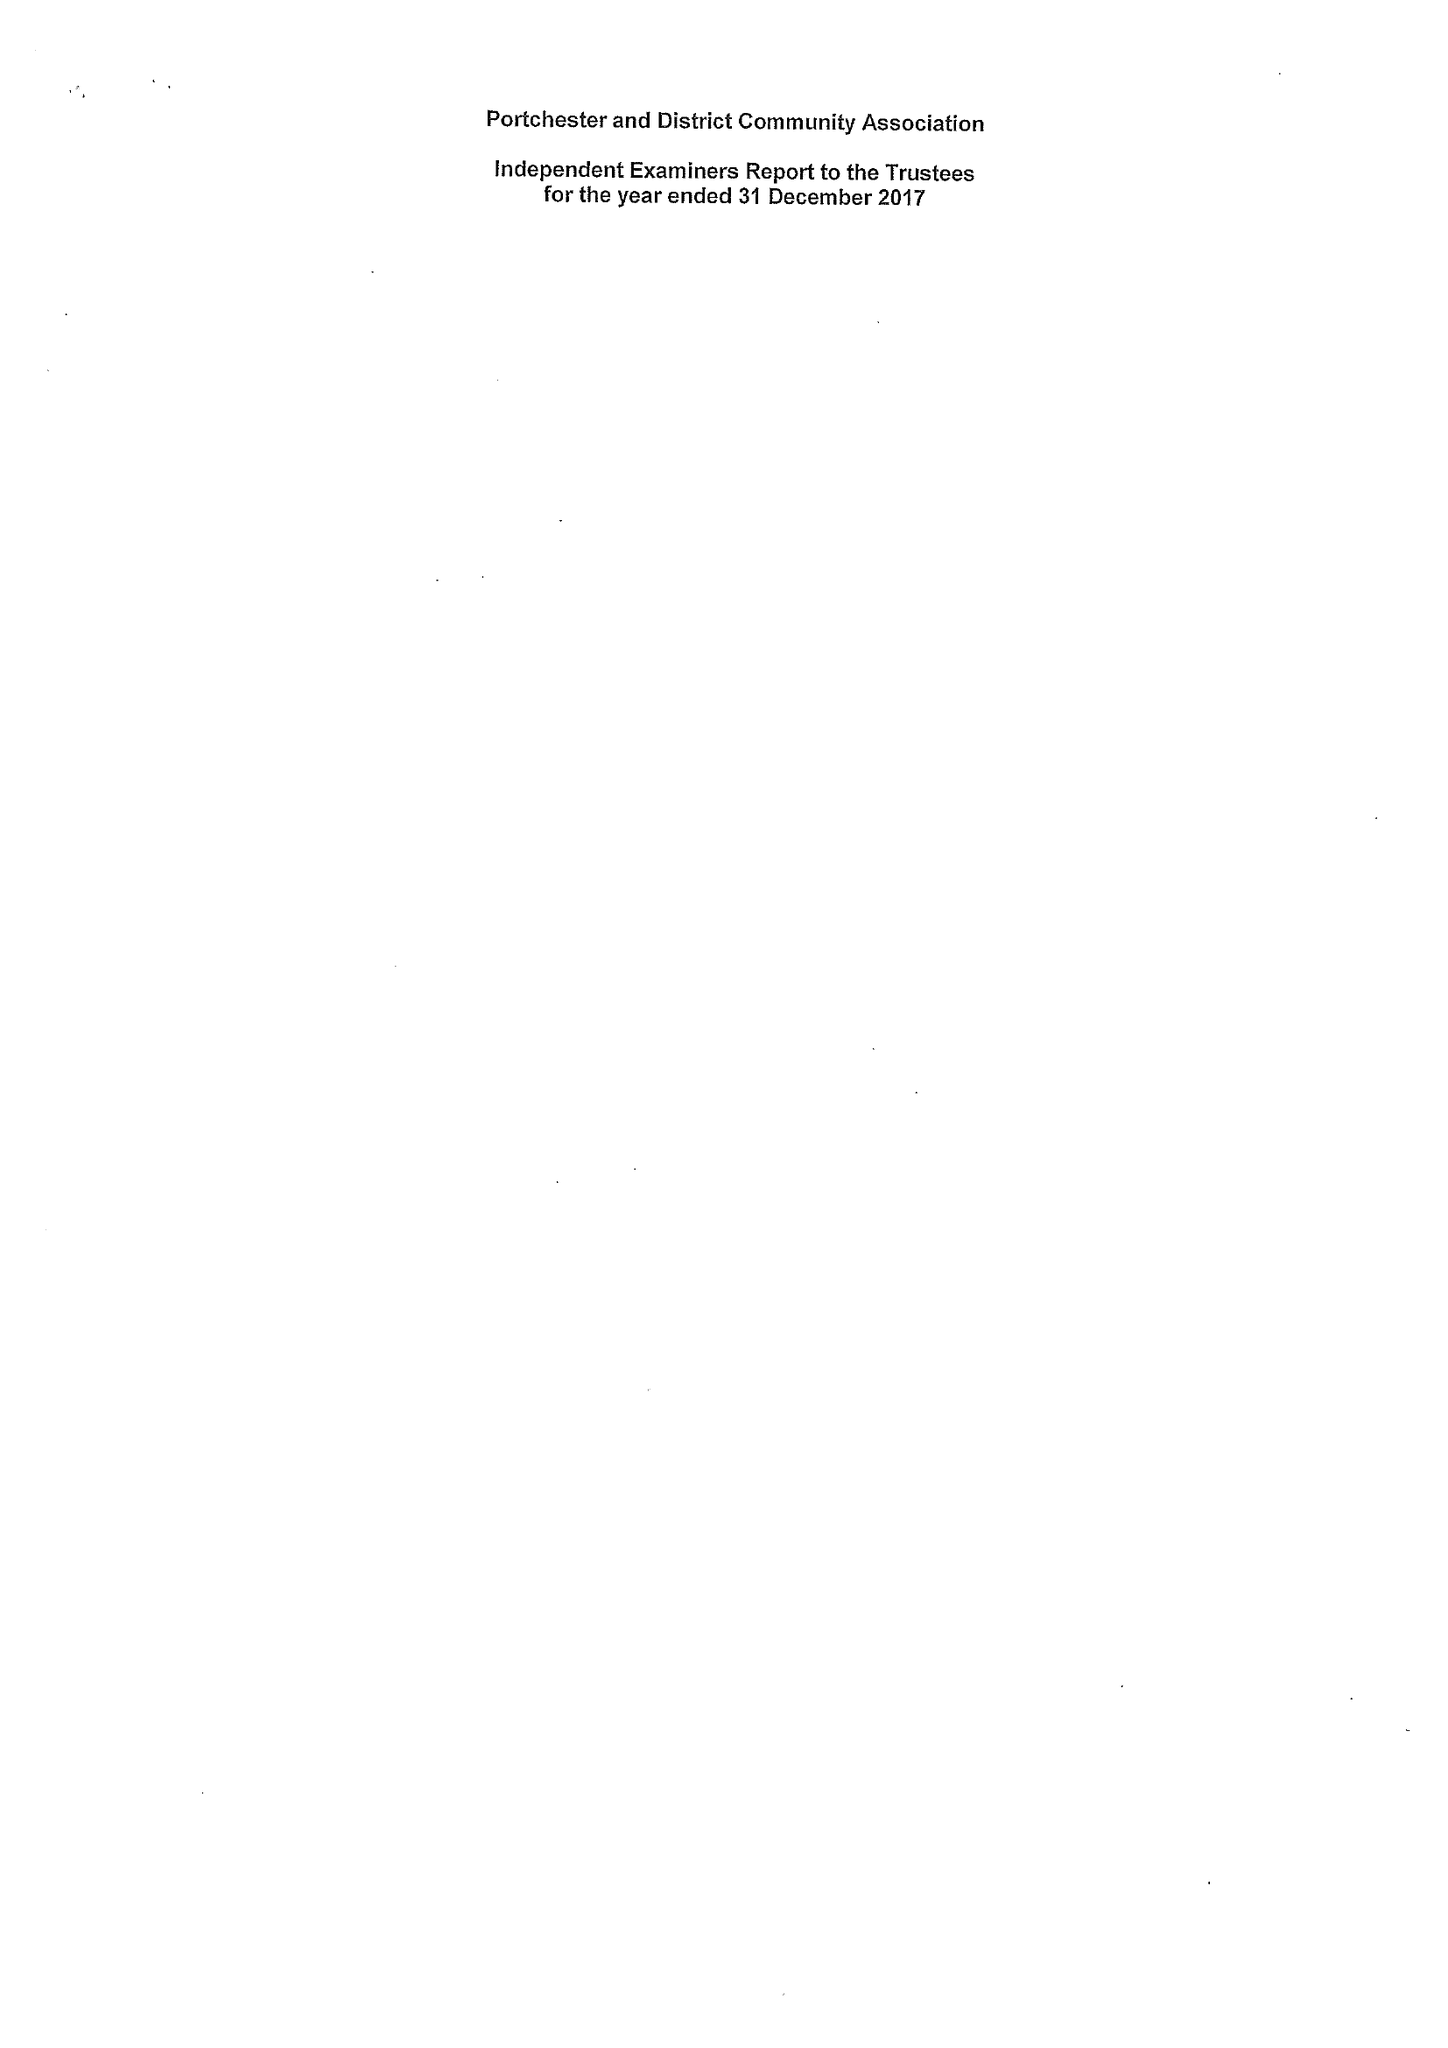What is the value for the report_date?
Answer the question using a single word or phrase. 2017-12-31 